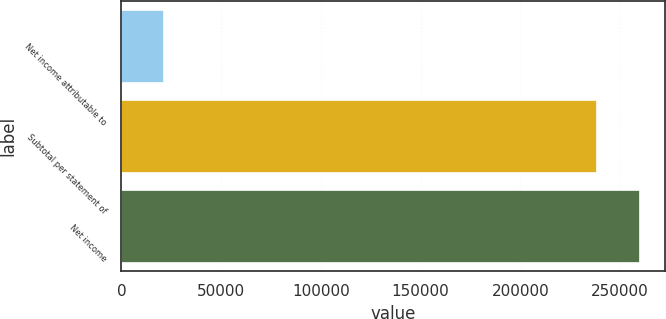<chart> <loc_0><loc_0><loc_500><loc_500><bar_chart><fcel>Net income attributable to<fcel>Subtotal per statement of<fcel>Net income<nl><fcel>20774<fcel>237919<fcel>259713<nl></chart> 